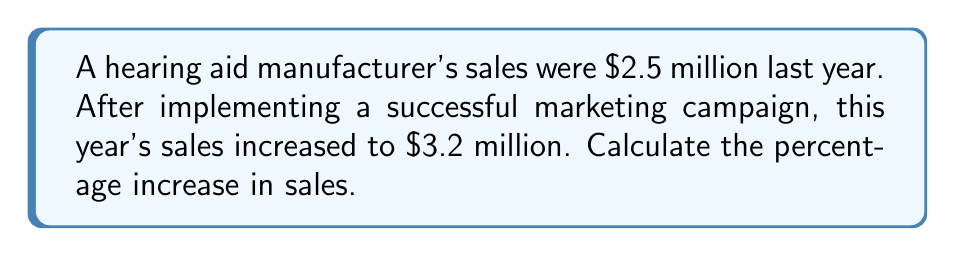Give your solution to this math problem. To calculate the percentage increase in sales, we need to follow these steps:

1. Calculate the difference in sales:
   $\text{Difference} = \text{New Sales} - \text{Original Sales}$
   $\text{Difference} = \$3.2 \text{ million} - \$2.5 \text{ million} = \$0.7 \text{ million}$

2. Divide the difference by the original sales:
   $\text{Fraction of increase} = \frac{\text{Difference}}{\text{Original Sales}}$
   $\text{Fraction of increase} = \frac{\$0.7 \text{ million}}{\$2.5 \text{ million}} = 0.28$

3. Convert the fraction to a percentage by multiplying by 100:
   $\text{Percentage increase} = \text{Fraction of increase} \times 100\%$
   $\text{Percentage increase} = 0.28 \times 100\% = 28\%$

Therefore, the percentage increase in sales after the successful marketing campaign is 28%.
Answer: 28% 